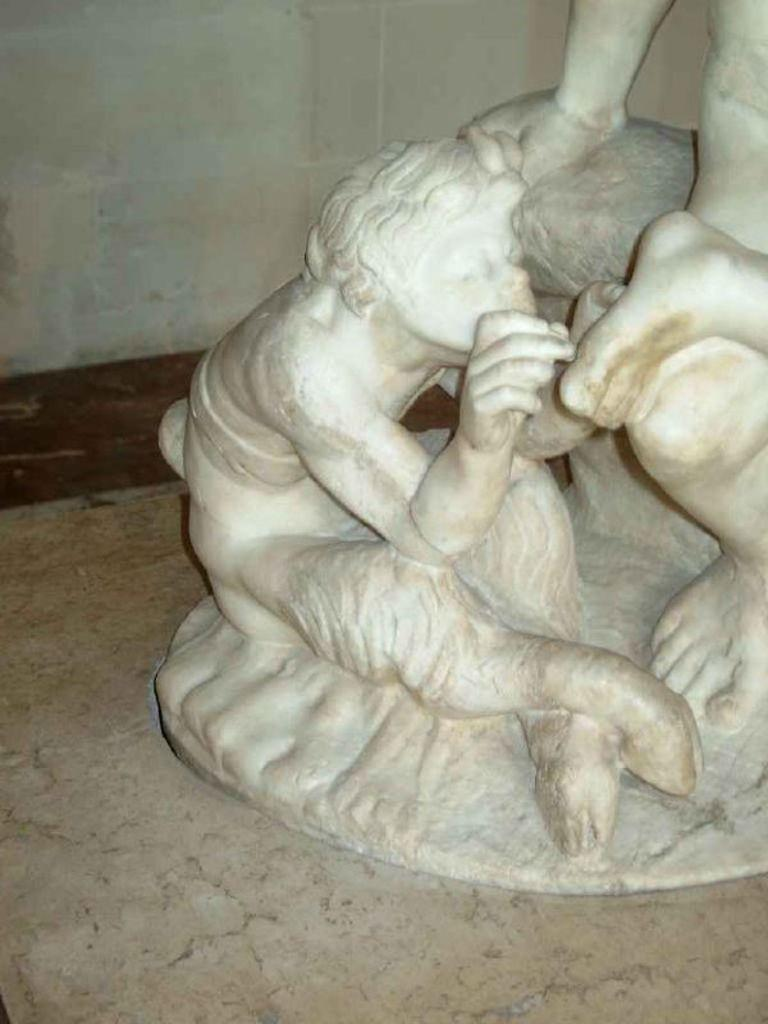What is the main subject of the image? There is a sculpture in the image. Where is the sculpture located? The sculpture is on a surface. What else can be seen in the image besides the sculpture? There is a wall visible in the image. Can you describe the relationship between the sculpture and the wall? The wall is on the backside of the sculpture. How many pumps are attached to the sculpture in the image? There are no pumps present in the image; it features a sculpture and a wall. Is the sculpture sleeping in the image? The sculpture is an inanimate object and cannot sleep. 